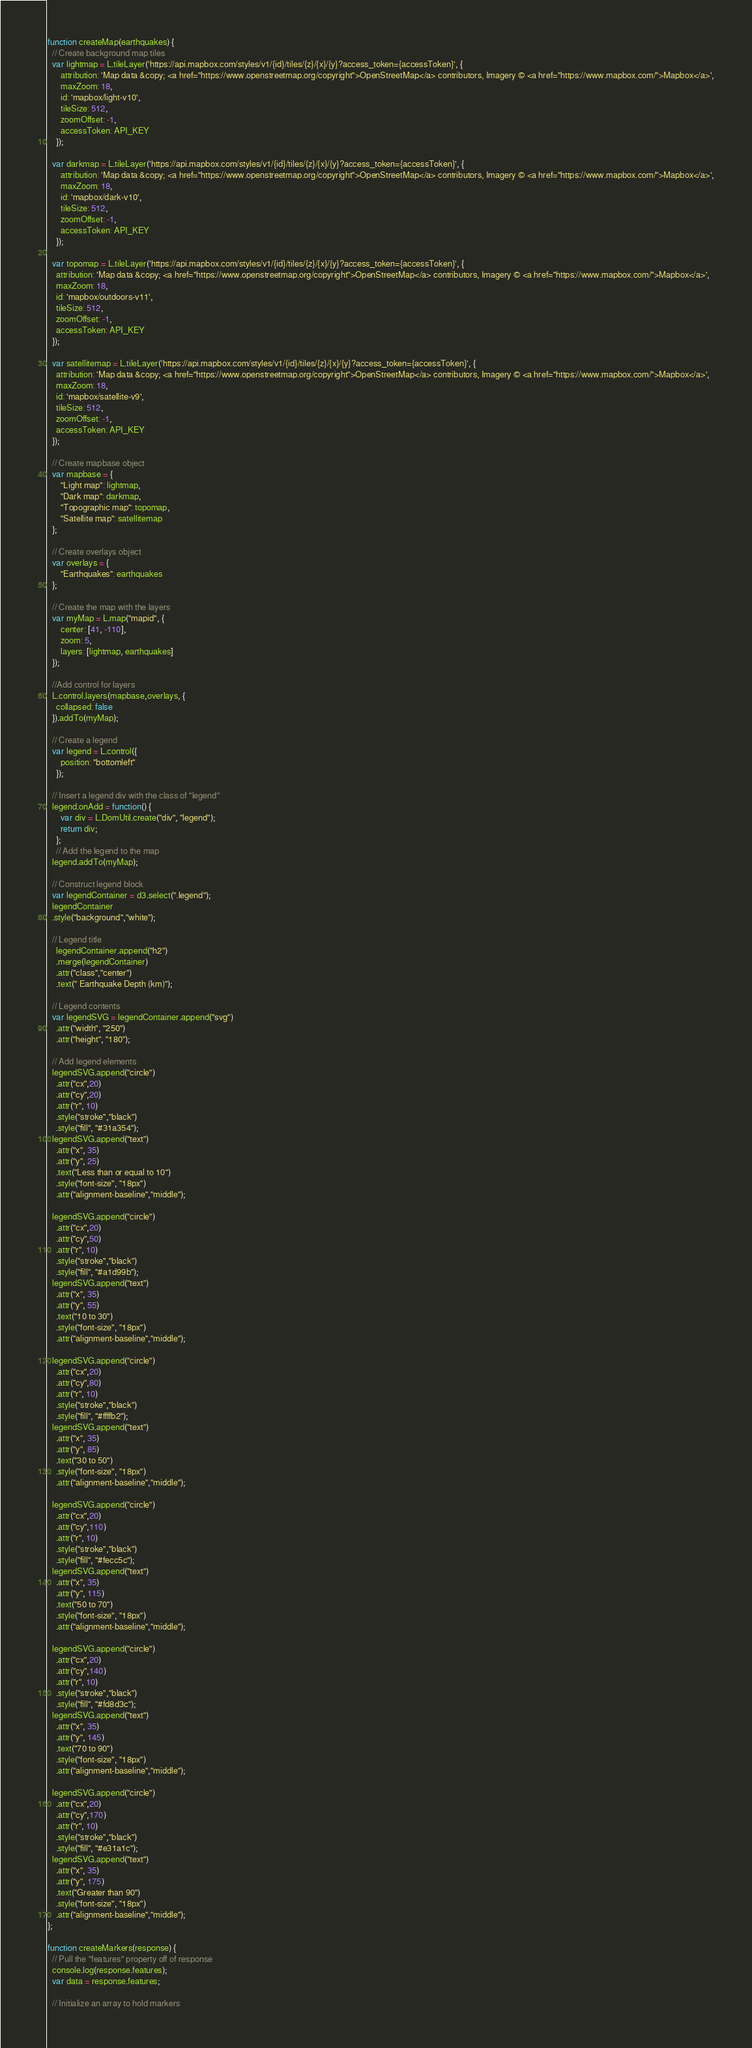Convert code to text. <code><loc_0><loc_0><loc_500><loc_500><_JavaScript_>function createMap(earthquakes) {
  // Create background map tiles
  var lightmap = L.tileLayer('https://api.mapbox.com/styles/v1/{id}/tiles/{z}/{x}/{y}?access_token={accessToken}', {
      attribution: 'Map data &copy; <a href="https://www.openstreetmap.org/copyright">OpenStreetMap</a> contributors, Imagery © <a href="https://www.mapbox.com/">Mapbox</a>',
      maxZoom: 18,
      id: 'mapbox/light-v10',
      tileSize: 512,
      zoomOffset: -1,
      accessToken: API_KEY
    });

  var darkmap = L.tileLayer('https://api.mapbox.com/styles/v1/{id}/tiles/{z}/{x}/{y}?access_token={accessToken}', {
      attribution: 'Map data &copy; <a href="https://www.openstreetmap.org/copyright">OpenStreetMap</a> contributors, Imagery © <a href="https://www.mapbox.com/">Mapbox</a>',
      maxZoom: 18,
      id: 'mapbox/dark-v10',
      tileSize: 512,
      zoomOffset: -1,
      accessToken: API_KEY
    });

  var topomap = L.tileLayer('https://api.mapbox.com/styles/v1/{id}/tiles/{z}/{x}/{y}?access_token={accessToken}', {
    attribution: 'Map data &copy; <a href="https://www.openstreetmap.org/copyright">OpenStreetMap</a> contributors, Imagery © <a href="https://www.mapbox.com/">Mapbox</a>',
    maxZoom: 18,
    id: 'mapbox/outdoors-v11',
    tileSize: 512,
    zoomOffset: -1,
    accessToken: API_KEY
  });

  var satellitemap = L.tileLayer('https://api.mapbox.com/styles/v1/{id}/tiles/{z}/{x}/{y}?access_token={accessToken}', {
    attribution: 'Map data &copy; <a href="https://www.openstreetmap.org/copyright">OpenStreetMap</a> contributors, Imagery © <a href="https://www.mapbox.com/">Mapbox</a>',
    maxZoom: 18,
    id: 'mapbox/satellite-v9',
    tileSize: 512,
    zoomOffset: -1,
    accessToken: API_KEY
  });

  // Create mapbase object
  var mapbase = {
      "Light map": lightmap,
      "Dark map": darkmap,
      "Topographic map": topomap,
      "Satellite map": satellitemap
  };

  // Create overlays object
  var overlays = {
      "Earthquakes": earthquakes
  };

  // Create the map with the layers
  var myMap = L.map("mapid", {
      center: [41, -110],
      zoom: 5,
      layers: [lightmap, earthquakes]
  });
  
  //Add control for layers
  L.control.layers(mapbase,overlays, {
    collapsed: false
  }).addTo(myMap);

  // Create a legend 
  var legend = L.control({
      position: "bottomleft"
    });

  // Insert a legend div with the class of "legend"
  legend.onAdd = function() {
      var div = L.DomUtil.create("div", "legend");
      return div;
    };
    // Add the legend to the map
  legend.addTo(myMap);

  // Construct legend block
  var legendContainer = d3.select(".legend");
  legendContainer
  .style("background","white");

  // Legend title
    legendContainer.append("h2")
    .merge(legendContainer)
    .attr("class","center")
    .text(" Earthquake Depth (km)");

  // Legend contents
  var legendSVG = legendContainer.append("svg")
    .attr("width", "250")
    .attr("height", "180");
  
  // Add legend elements
  legendSVG.append("circle")
    .attr("cx",20)
    .attr("cy",20)
    .attr("r", 10)
    .style("stroke","black")
    .style("fill", "#31a354");
  legendSVG.append("text")
    .attr("x", 35)
    .attr("y", 25)
    .text("Less than or equal to 10")
    .style("font-size", "18px")
    .attr("alignment-baseline","middle");

  legendSVG.append("circle")
    .attr("cx",20)
    .attr("cy",50)
    .attr("r", 10)
    .style("stroke","black")
    .style("fill", "#a1d99b");
  legendSVG.append("text")
    .attr("x", 35)
    .attr("y", 55)
    .text("10 to 30")
    .style("font-size", "18px")
    .attr("alignment-baseline","middle");

  legendSVG.append("circle")
    .attr("cx",20)
    .attr("cy",80)
    .attr("r", 10)
    .style("stroke","black")
    .style("fill", "#ffffb2");
  legendSVG.append("text")
    .attr("x", 35)
    .attr("y", 85)
    .text("30 to 50")
    .style("font-size", "18px")
    .attr("alignment-baseline","middle");

  legendSVG.append("circle")
    .attr("cx",20)
    .attr("cy",110)
    .attr("r", 10)
    .style("stroke","black")
    .style("fill", "#fecc5c");
  legendSVG.append("text")
    .attr("x", 35)
    .attr("y", 115)
    .text("50 to 70")
    .style("font-size", "18px")
    .attr("alignment-baseline","middle");

  legendSVG.append("circle")
    .attr("cx",20)
    .attr("cy",140)
    .attr("r", 10)
    .style("stroke","black")
    .style("fill", "#fd8d3c");
  legendSVG.append("text")
    .attr("x", 35)
    .attr("y", 145)
    .text("70 to 90")
    .style("font-size", "18px")
    .attr("alignment-baseline","middle");

  legendSVG.append("circle")
    .attr("cx",20)
    .attr("cy",170)
    .attr("r", 10)
    .style("stroke","black")
    .style("fill", "#e31a1c");
  legendSVG.append("text")
    .attr("x", 35)
    .attr("y", 175)
    .text("Greater than 90")
    .style("font-size", "18px")
    .attr("alignment-baseline","middle");
};

function createMarkers(response) {
  // Pull the "features" property off of response
  console.log(response.features);
  var data = response.features;

  // Initialize an array to hold markers</code> 